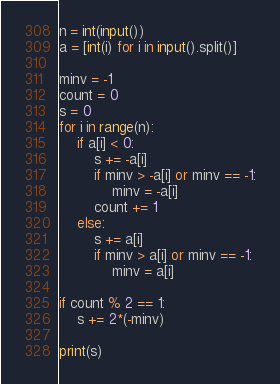<code> <loc_0><loc_0><loc_500><loc_500><_Python_>n = int(input())
a = [int(i) for i in input().split()]

minv = -1
count = 0
s = 0
for i in range(n):
    if a[i] < 0:
        s += -a[i]
        if minv > -a[i] or minv == -1:
            minv = -a[i]
        count += 1
    else:
        s += a[i]
        if minv > a[i] or minv == -1:
            minv = a[i]

if count % 2 == 1:
    s += 2*(-minv)

print(s)
</code> 